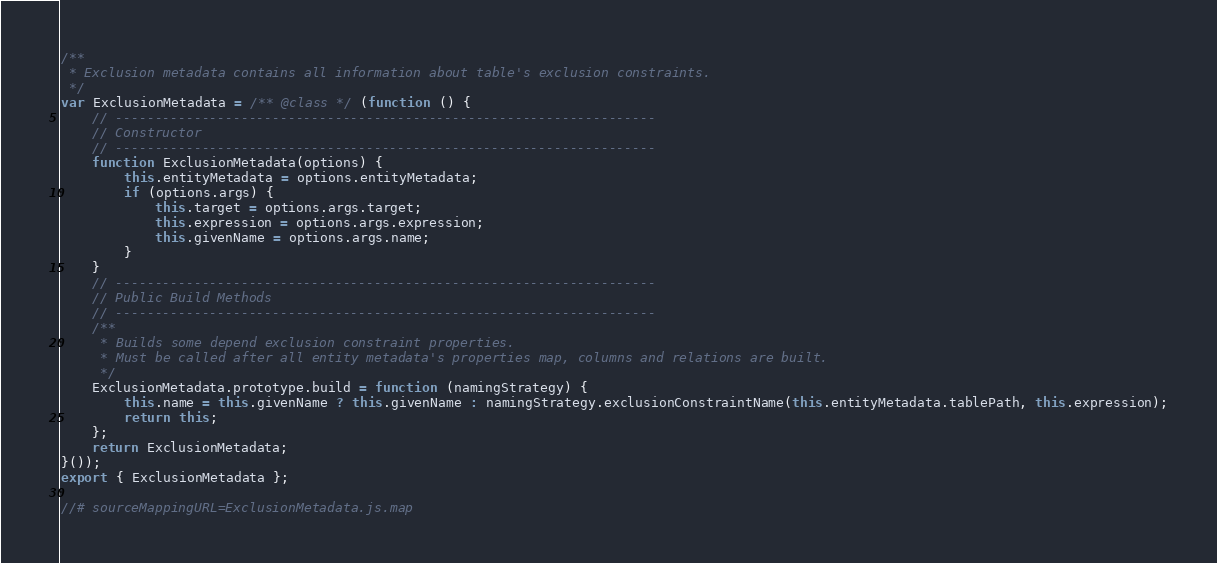Convert code to text. <code><loc_0><loc_0><loc_500><loc_500><_JavaScript_>/**
 * Exclusion metadata contains all information about table's exclusion constraints.
 */
var ExclusionMetadata = /** @class */ (function () {
    // ---------------------------------------------------------------------
    // Constructor
    // ---------------------------------------------------------------------
    function ExclusionMetadata(options) {
        this.entityMetadata = options.entityMetadata;
        if (options.args) {
            this.target = options.args.target;
            this.expression = options.args.expression;
            this.givenName = options.args.name;
        }
    }
    // ---------------------------------------------------------------------
    // Public Build Methods
    // ---------------------------------------------------------------------
    /**
     * Builds some depend exclusion constraint properties.
     * Must be called after all entity metadata's properties map, columns and relations are built.
     */
    ExclusionMetadata.prototype.build = function (namingStrategy) {
        this.name = this.givenName ? this.givenName : namingStrategy.exclusionConstraintName(this.entityMetadata.tablePath, this.expression);
        return this;
    };
    return ExclusionMetadata;
}());
export { ExclusionMetadata };

//# sourceMappingURL=ExclusionMetadata.js.map
</code> 